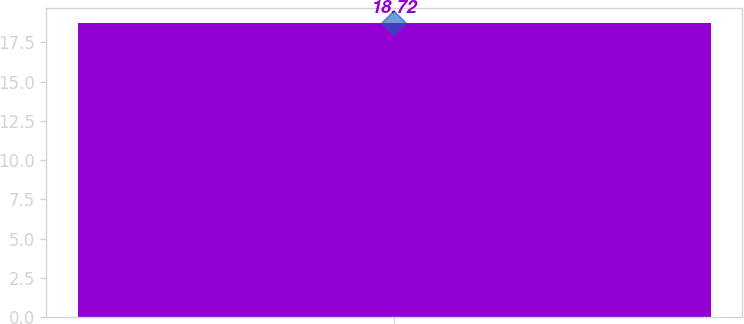Convert chart to OTSL. <chart><loc_0><loc_0><loc_500><loc_500><bar_chart><ecel><nl><fcel>18.72<nl></chart> 